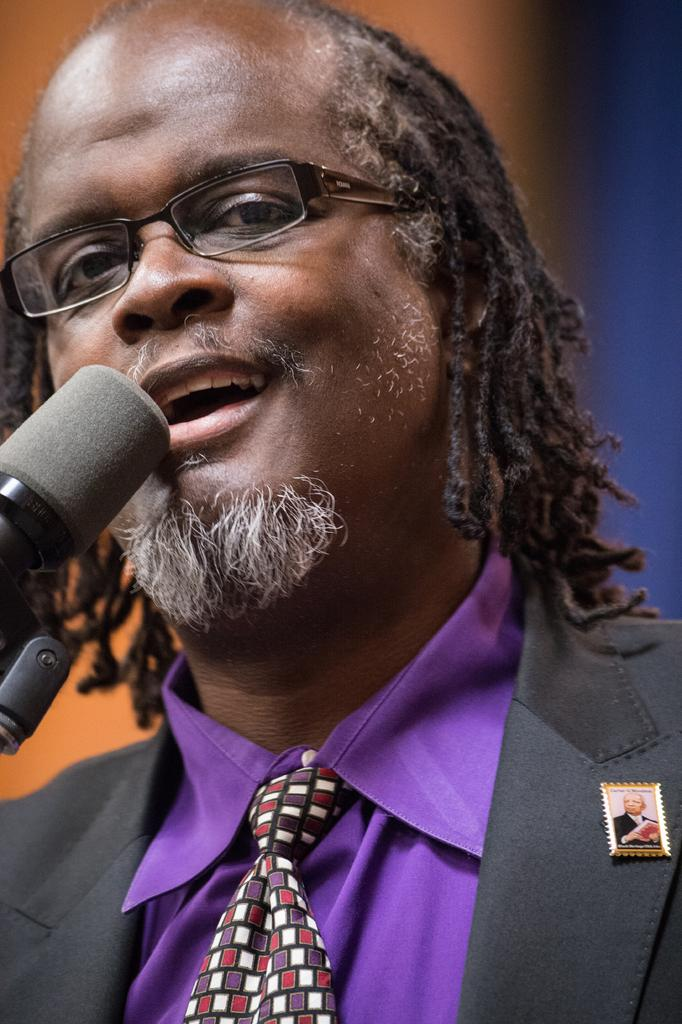What is the main subject of the image? There is a person in the image. What is the person wearing on their upper body? The person is wearing a black color blazer and a purple color shirt. What accessories can be seen on the person? The person is wearing a badge, a tie, and spectacles. What is the person holding in their hand? The person is holding a mic. Can you describe the background of the image? The background of the image is blurred. How many turkeys can be seen in the image? There are no turkeys present in the image. Is the person skating in the image? There is no indication of the person skating in the image. 